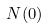Convert formula to latex. <formula><loc_0><loc_0><loc_500><loc_500>N ( 0 )</formula> 